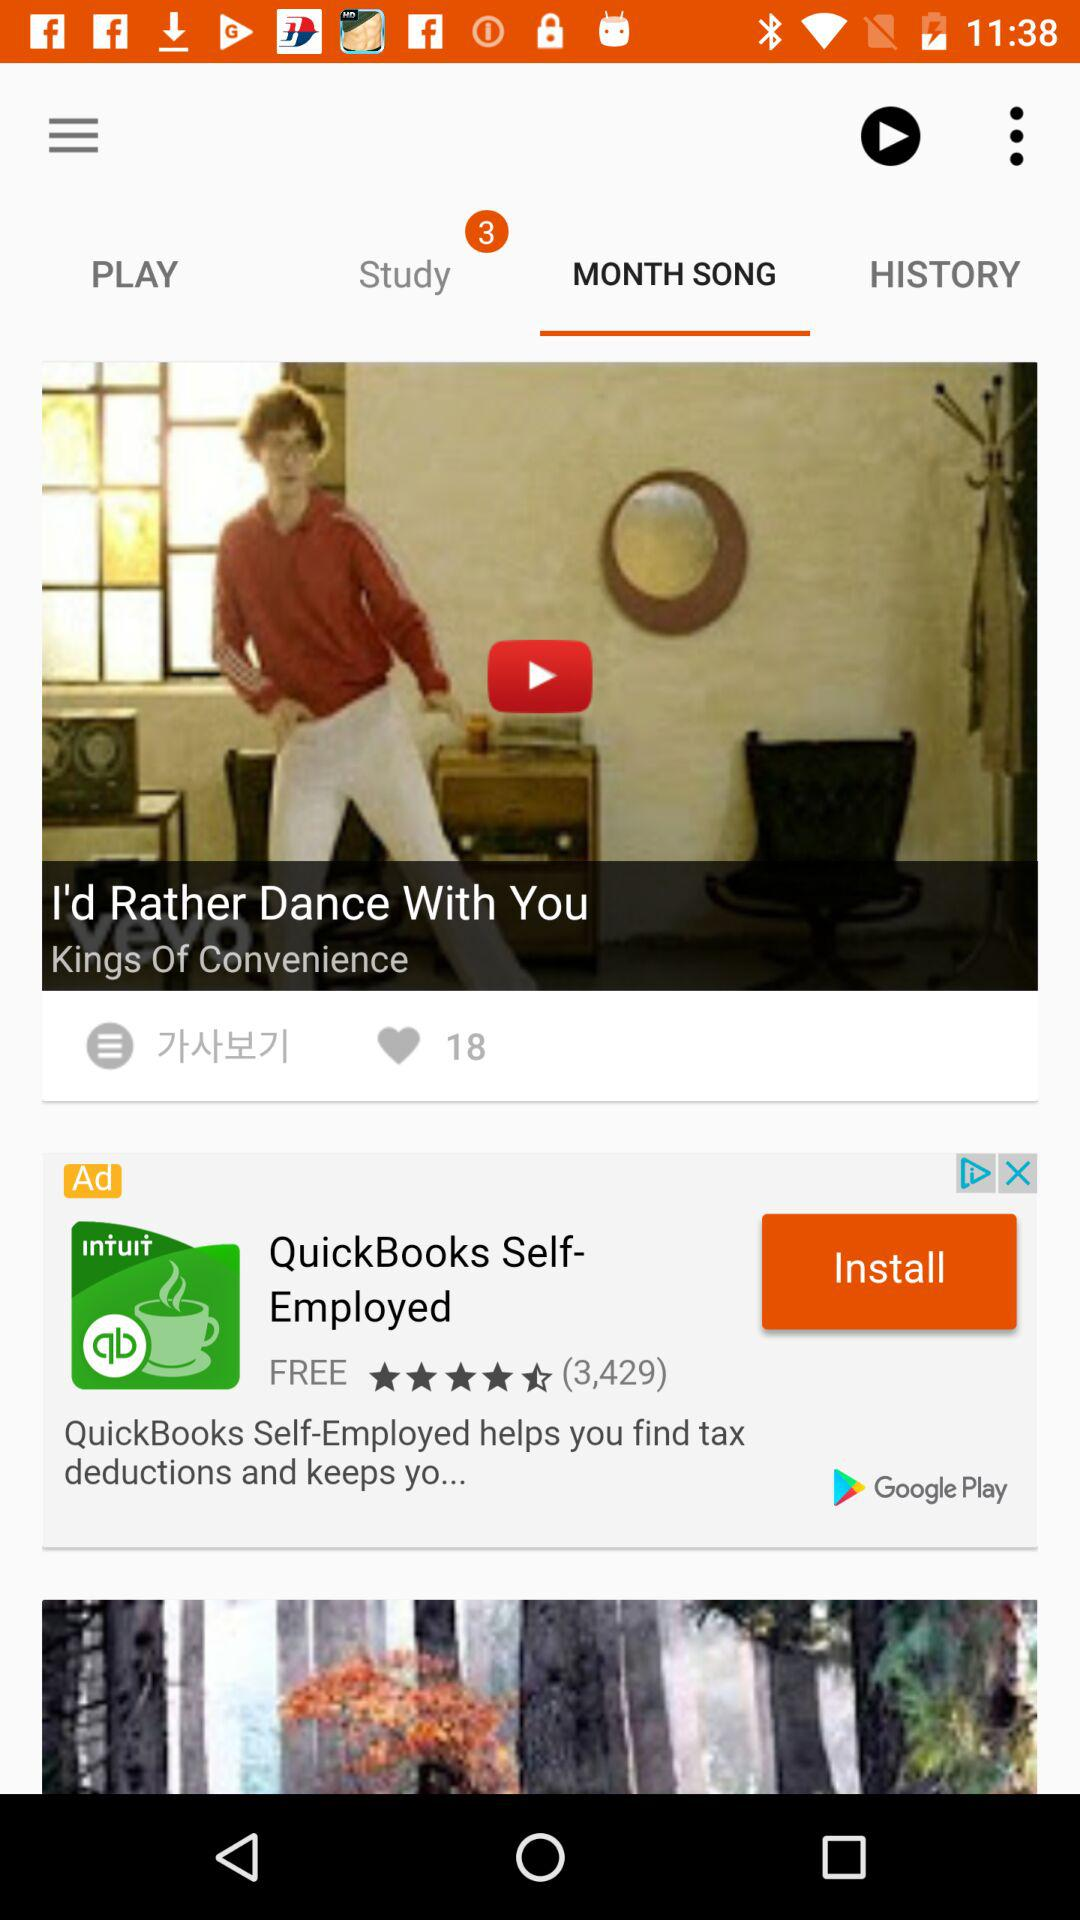How many likes are of the video? There are 18 likes of the video. 